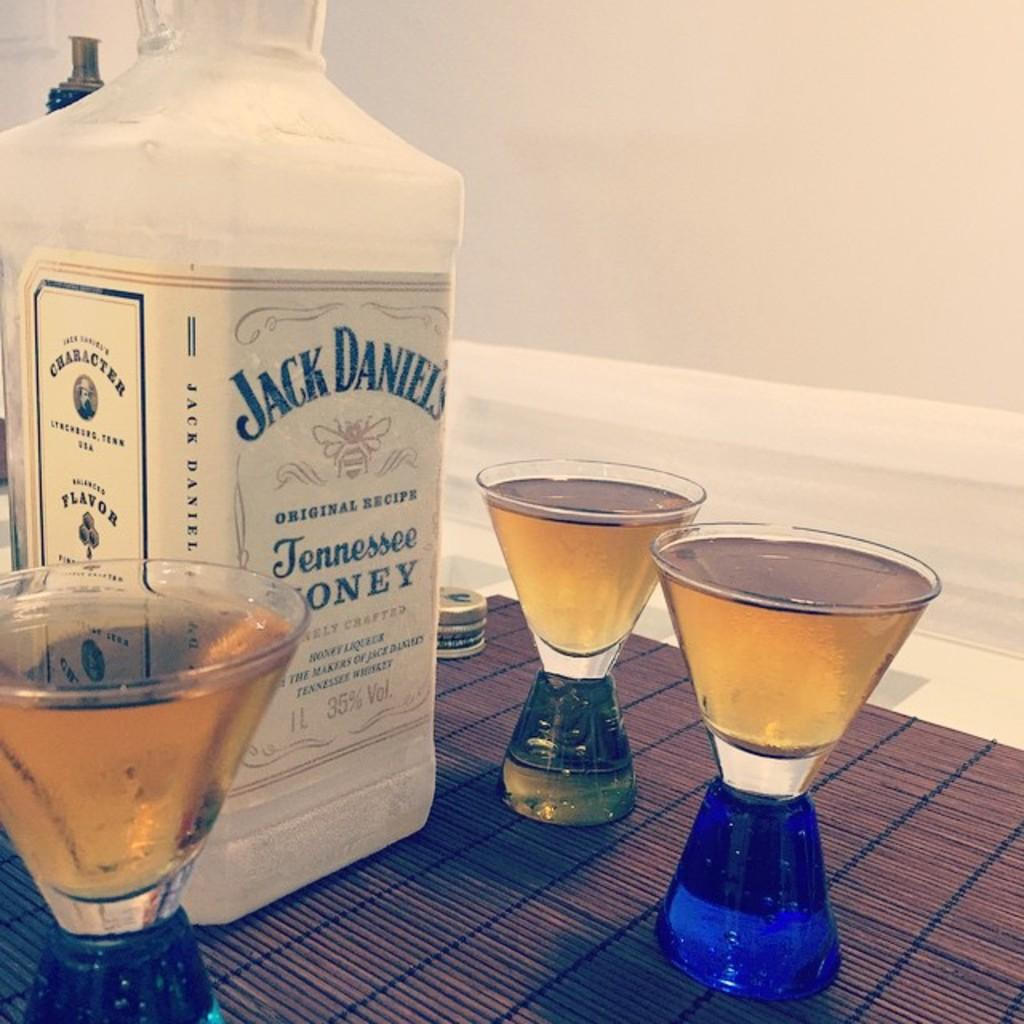<image>
Create a compact narrative representing the image presented. A bottle of Jack Daniels is surrounded by full glasses. 